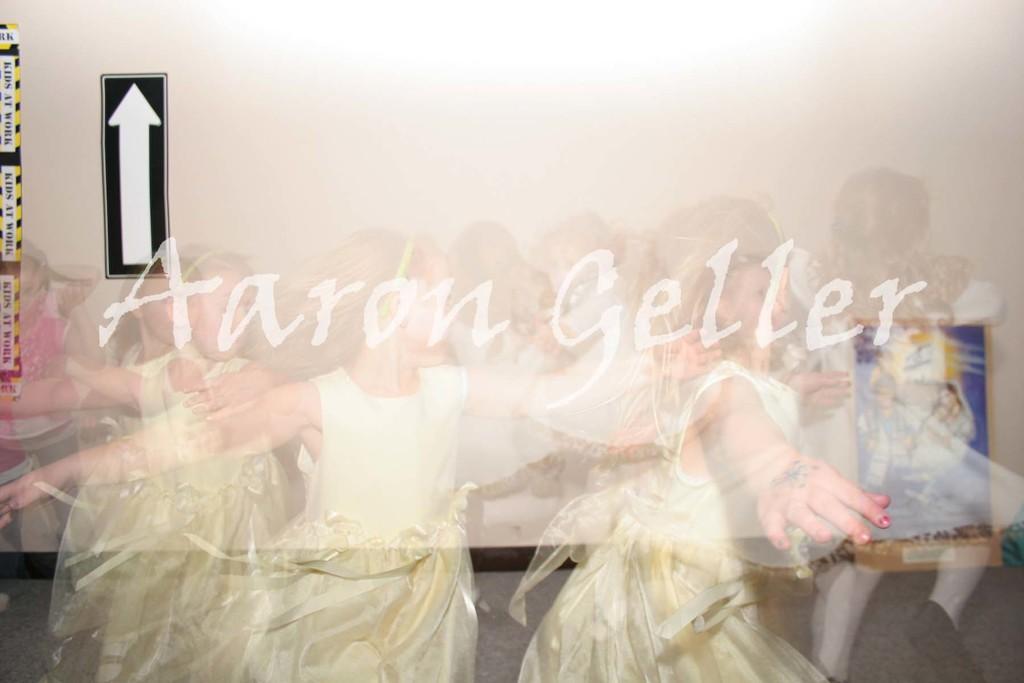How would you summarize this image in a sentence or two? This is an edited image. In the center of the image there is a text. There are girls. In the background of the image there is wall. There is a sign. 